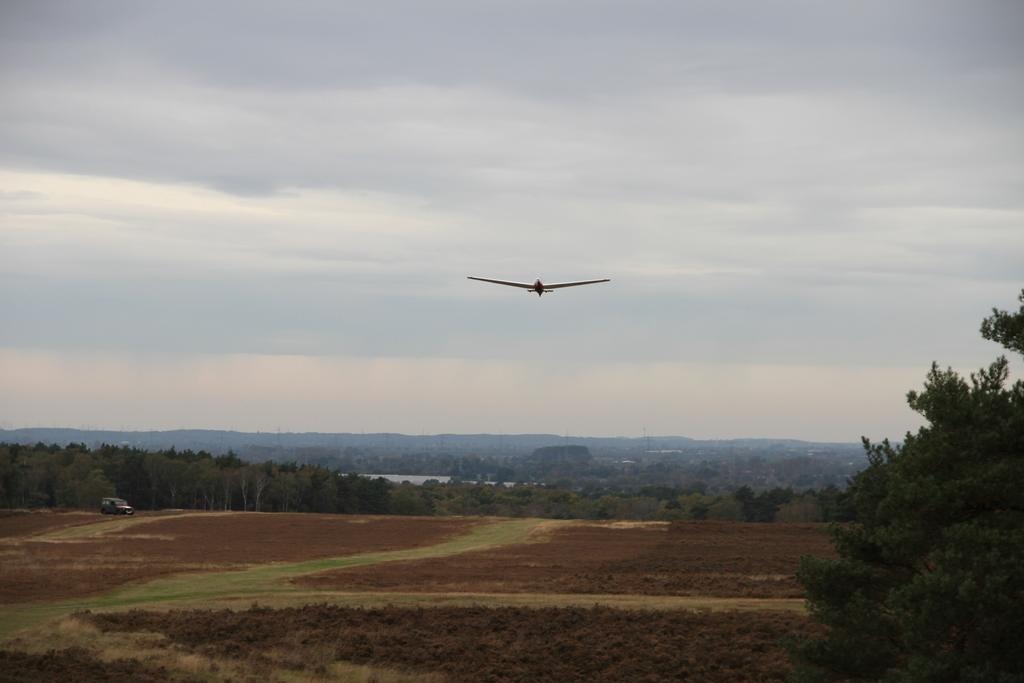What type of natural elements are present in the image? There are trees and plants in the image. Where are the trees and plants located? The trees and plants are on the ground. What else can be seen on the right side of the image? There is a vehicle on the right side of the image. What is happening in the sky in the image? An airplane is flying in the sky in the image. What type of business is being conducted in the mountains in the image? There are no mountains or business activities present in the image. 